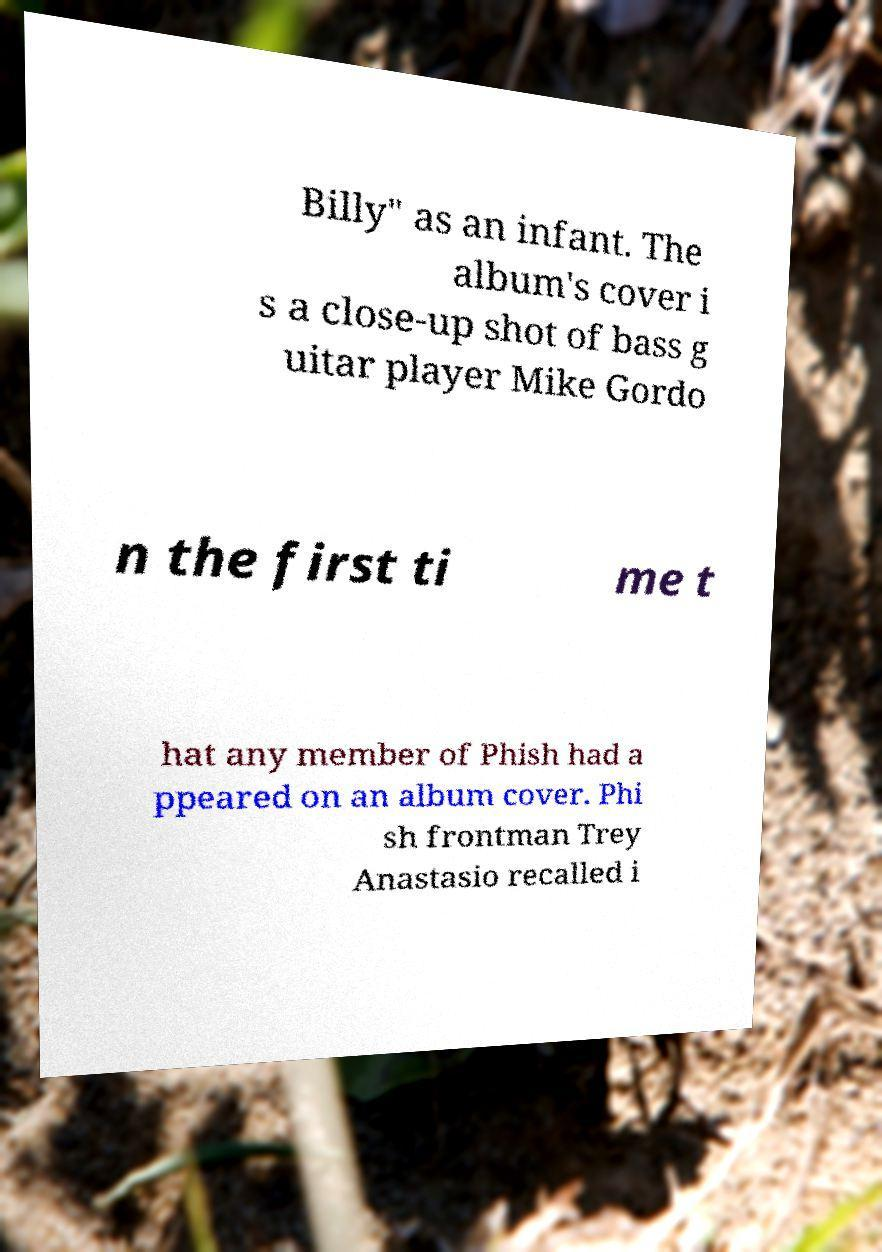Could you assist in decoding the text presented in this image and type it out clearly? Billy" as an infant. The album's cover i s a close-up shot of bass g uitar player Mike Gordo n the first ti me t hat any member of Phish had a ppeared on an album cover. Phi sh frontman Trey Anastasio recalled i 